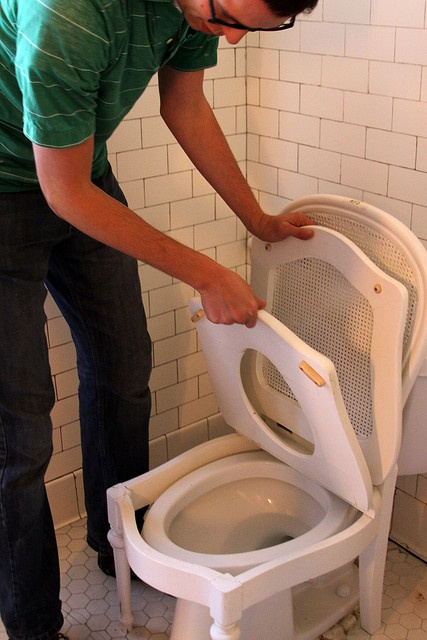Describe the objects in this image and their specific colors. I can see toilet in turquoise, gray, tan, and darkgray tones and people in turquoise, black, brown, and maroon tones in this image. 